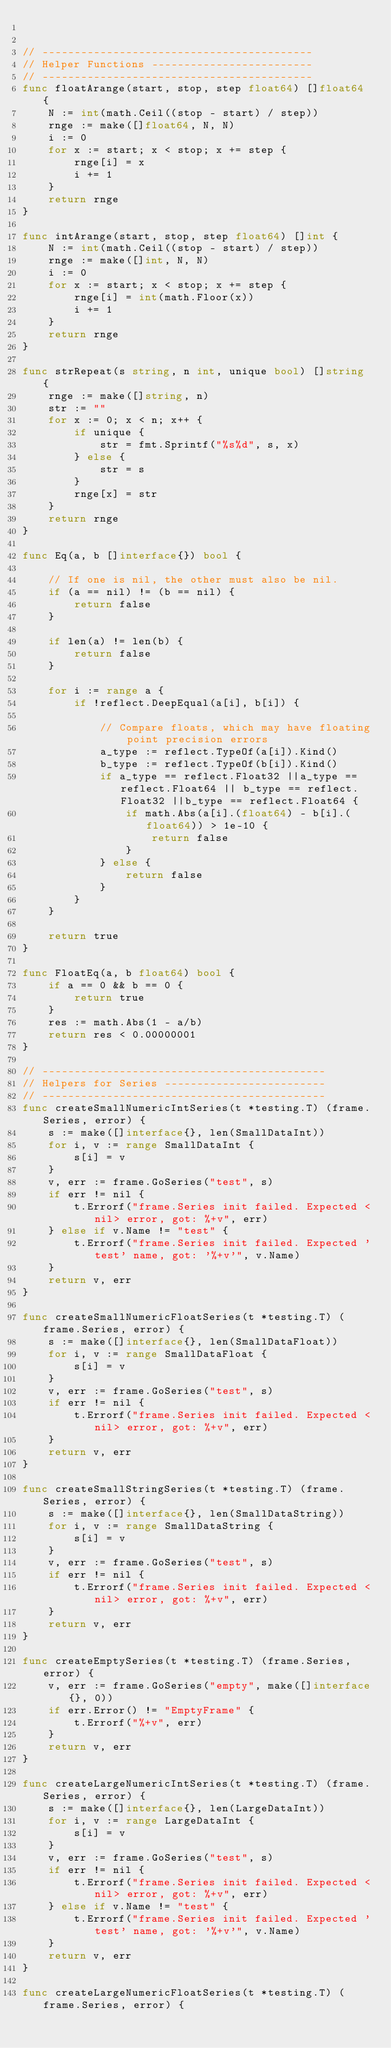<code> <loc_0><loc_0><loc_500><loc_500><_Go_>

// ------------------------------------------
// Helper Functions -------------------------
// ------------------------------------------
func floatArange(start, stop, step float64) []float64 {
	N := int(math.Ceil((stop - start) / step))
	rnge := make([]float64, N, N)
	i := 0
	for x := start; x < stop; x += step {
		rnge[i] = x
		i += 1
	}
	return rnge
}

func intArange(start, stop, step float64) []int {
	N := int(math.Ceil((stop - start) / step))
	rnge := make([]int, N, N)
	i := 0
	for x := start; x < stop; x += step {
		rnge[i] = int(math.Floor(x))
		i += 1
	}
	return rnge
}

func strRepeat(s string, n int, unique bool) []string {
	rnge := make([]string, n)
	str := ""
	for x := 0; x < n; x++ {
		if unique {
			str = fmt.Sprintf("%s%d", s, x)
		} else {
			str = s
		}
		rnge[x] = str
	}
	return rnge
}

func Eq(a, b []interface{}) bool {

	// If one is nil, the other must also be nil.
	if (a == nil) != (b == nil) {
		return false
	}

	if len(a) != len(b) {
		return false
	}

	for i := range a {
		if !reflect.DeepEqual(a[i], b[i]) {

			// Compare floats, which may have floating point precision errors
			a_type := reflect.TypeOf(a[i]).Kind()
			b_type := reflect.TypeOf(b[i]).Kind()
			if a_type == reflect.Float32 ||a_type == reflect.Float64 || b_type == reflect.Float32 ||b_type == reflect.Float64 {
				if math.Abs(a[i].(float64) - b[i].(float64)) > 1e-10 {
					return false
				}
			} else {
				return false
			}
		}
	}

	return true
}

func FloatEq(a, b float64) bool {
	if a == 0 && b == 0 {
		return true
	}
	res := math.Abs(1 - a/b)
	return res < 0.00000001
}

// --------------------------------------------
// Helpers for Series -------------------------
// --------------------------------------------
func createSmallNumericIntSeries(t *testing.T) (frame.Series, error) {
	s := make([]interface{}, len(SmallDataInt))
	for i, v := range SmallDataInt {
		s[i] = v
	}
	v, err := frame.GoSeries("test", s)
	if err != nil {
		t.Errorf("frame.Series init failed. Expected <nil> error, got: %+v", err)
	} else if v.Name != "test" {
		t.Errorf("frame.Series init failed. Expected 'test' name, got: '%+v'", v.Name)
	}
	return v, err
}

func createSmallNumericFloatSeries(t *testing.T) (frame.Series, error) {
	s := make([]interface{}, len(SmallDataFloat))
	for i, v := range SmallDataFloat {
		s[i] = v
	}
	v, err := frame.GoSeries("test", s)
	if err != nil {
		t.Errorf("frame.Series init failed. Expected <nil> error, got: %+v", err)
	}
	return v, err
}

func createSmallStringSeries(t *testing.T) (frame.Series, error) {
	s := make([]interface{}, len(SmallDataString))
	for i, v := range SmallDataString {
		s[i] = v
	}
	v, err := frame.GoSeries("test", s)
	if err != nil {
		t.Errorf("frame.Series init failed. Expected <nil> error, got: %+v", err)
	}
	return v, err
}

func createEmptySeries(t *testing.T) (frame.Series, error) {
	v, err := frame.GoSeries("empty", make([]interface{}, 0))
	if err.Error() != "EmptyFrame" {
		t.Errorf("%+v", err)
	}
	return v, err
}

func createLargeNumericIntSeries(t *testing.T) (frame.Series, error) {
	s := make([]interface{}, len(LargeDataInt))
	for i, v := range LargeDataInt {
		s[i] = v
	}
	v, err := frame.GoSeries("test", s)
	if err != nil {
		t.Errorf("frame.Series init failed. Expected <nil> error, got: %+v", err)
	} else if v.Name != "test" {
		t.Errorf("frame.Series init failed. Expected 'test' name, got: '%+v'", v.Name)
	}
	return v, err
}

func createLargeNumericFloatSeries(t *testing.T) (frame.Series, error) {</code> 